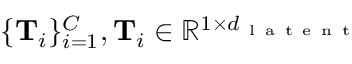<formula> <loc_0><loc_0><loc_500><loc_500>\{ T _ { i } \} _ { i = 1 } ^ { C } , T _ { i } \in \mathbb { R } ^ { 1 \times d _ { l a t e n t } }</formula> 